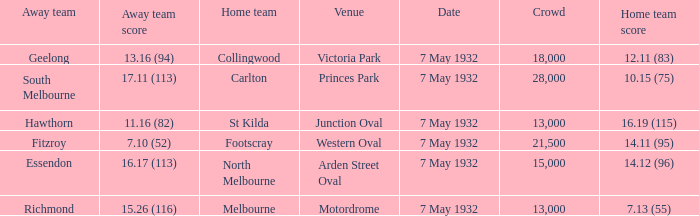What is the largest crowd with Away team score of 13.16 (94)? 18000.0. 